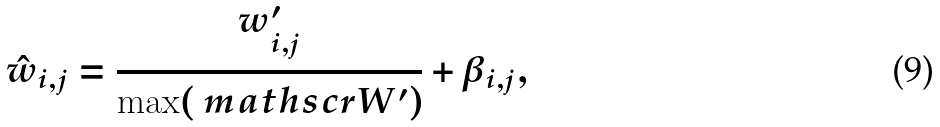<formula> <loc_0><loc_0><loc_500><loc_500>\hat { w } _ { i , j } = \frac { w ^ { \prime } _ { i , j } } { \max ( \ m a t h s c r { W ^ { \prime } } ) } + \beta _ { i , j } ,</formula> 